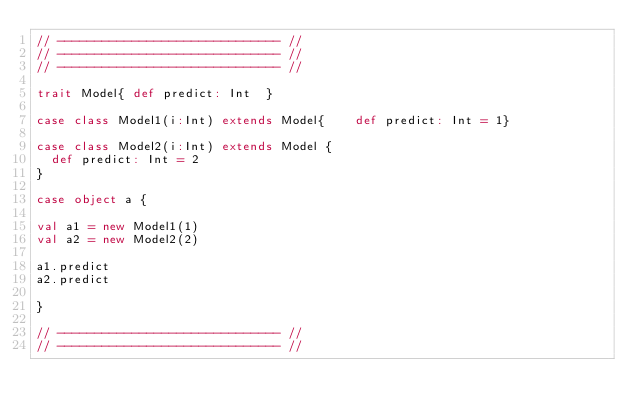Convert code to text. <code><loc_0><loc_0><loc_500><loc_500><_Scala_>// ------------------------------ //
// ------------------------------ //
// ------------------------------ //

trait Model{ def predict: Int  }

case class Model1(i:Int) extends Model{    def predict: Int = 1}

case class Model2(i:Int) extends Model {
  def predict: Int = 2
}

case object a {

val a1 = new Model1(1)
val a2 = new Model2(2)

a1.predict
a2.predict

}

// ------------------------------ //
// ------------------------------ //</code> 